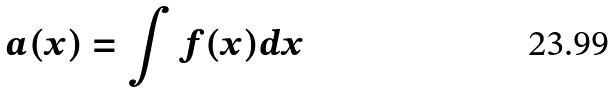<formula> <loc_0><loc_0><loc_500><loc_500>a ( x ) = \int f ( x ) d x</formula> 